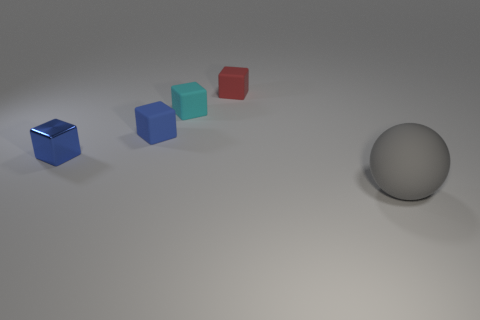Add 2 large yellow metal cylinders. How many objects exist? 7 Subtract all balls. How many objects are left? 4 Subtract 0 purple cylinders. How many objects are left? 5 Subtract all big gray matte balls. Subtract all blue metallic blocks. How many objects are left? 3 Add 2 tiny cyan things. How many tiny cyan things are left? 3 Add 4 tiny blue metallic objects. How many tiny blue metallic objects exist? 5 